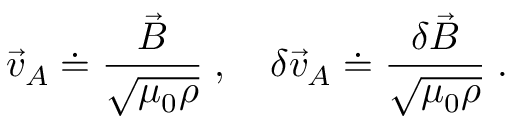Convert formula to latex. <formula><loc_0><loc_0><loc_500><loc_500>\vec { v } _ { A } \doteq \frac { \vec { B } } { \sqrt { \mu _ { 0 } \rho } } \, , \quad \delta \vec { v } _ { A } \doteq \frac { \delta \vec { B } } { \sqrt { \mu _ { 0 } \rho } } \, .</formula> 